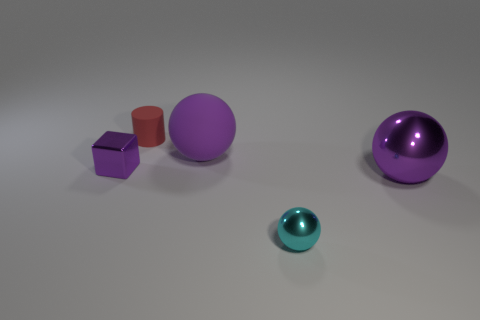Subtract all big purple metallic spheres. How many spheres are left? 2 Subtract all gray blocks. How many purple spheres are left? 2 Add 4 tiny rubber objects. How many objects exist? 9 Subtract all blocks. How many objects are left? 4 Subtract all yellow spheres. Subtract all brown cylinders. How many spheres are left? 3 Add 2 large rubber objects. How many large rubber objects exist? 3 Subtract 0 cyan cylinders. How many objects are left? 5 Subtract all big blue metal objects. Subtract all metal cubes. How many objects are left? 4 Add 1 matte objects. How many matte objects are left? 3 